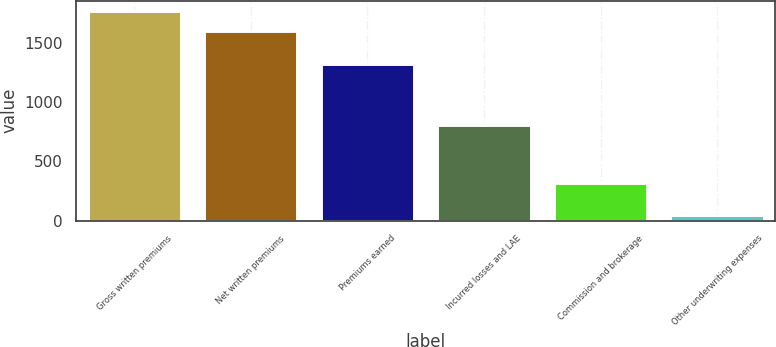<chart> <loc_0><loc_0><loc_500><loc_500><bar_chart><fcel>Gross written premiums<fcel>Net written premiums<fcel>Premiums earned<fcel>Incurred losses and LAE<fcel>Commission and brokerage<fcel>Other underwriting expenses<nl><fcel>1767.77<fcel>1605.5<fcel>1324.2<fcel>808.7<fcel>319.2<fcel>43.6<nl></chart> 